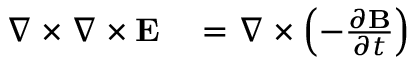<formula> <loc_0><loc_0><loc_500><loc_500>\begin{array} { r l r } { \nabla \times \nabla \times { \mathbf E } } & = \nabla \times \left ( - \frac { \partial { \mathbf B } } { \partial t } \right ) } \end{array}</formula> 